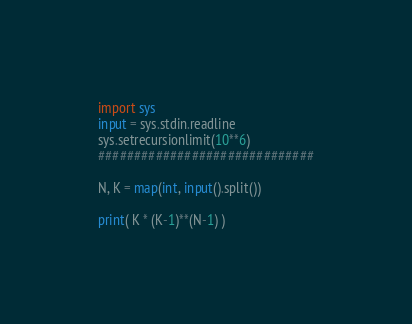Convert code to text. <code><loc_0><loc_0><loc_500><loc_500><_Python_>
import sys
input = sys.stdin.readline
sys.setrecursionlimit(10**6)
##############################

N, K = map(int, input().split())

print( K * (K-1)**(N-1) )</code> 